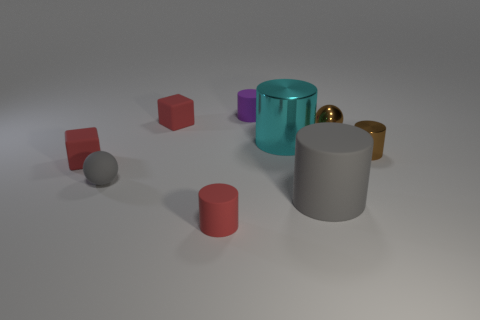Is the shape of the tiny purple object the same as the small gray object?
Make the answer very short. No. There is a big gray matte thing; are there any small cylinders in front of it?
Provide a short and direct response. Yes. How many things are big green matte balls or cyan metal cylinders?
Make the answer very short. 1. How many other things are the same size as the purple matte thing?
Provide a short and direct response. 6. How many small spheres are both behind the gray matte sphere and in front of the shiny sphere?
Give a very brief answer. 0. There is a red block that is behind the tiny brown cylinder; does it have the same size as the gray rubber thing right of the big metal cylinder?
Your response must be concise. No. There is a ball on the right side of the gray rubber ball; how big is it?
Provide a short and direct response. Small. What number of things are gray matte things left of the small purple cylinder or red blocks in front of the big cyan cylinder?
Your answer should be very brief. 2. Is there any other thing of the same color as the big matte thing?
Keep it short and to the point. Yes. Are there the same number of purple rubber objects that are in front of the brown metal cylinder and gray rubber spheres that are left of the tiny gray matte ball?
Ensure brevity in your answer.  Yes. 